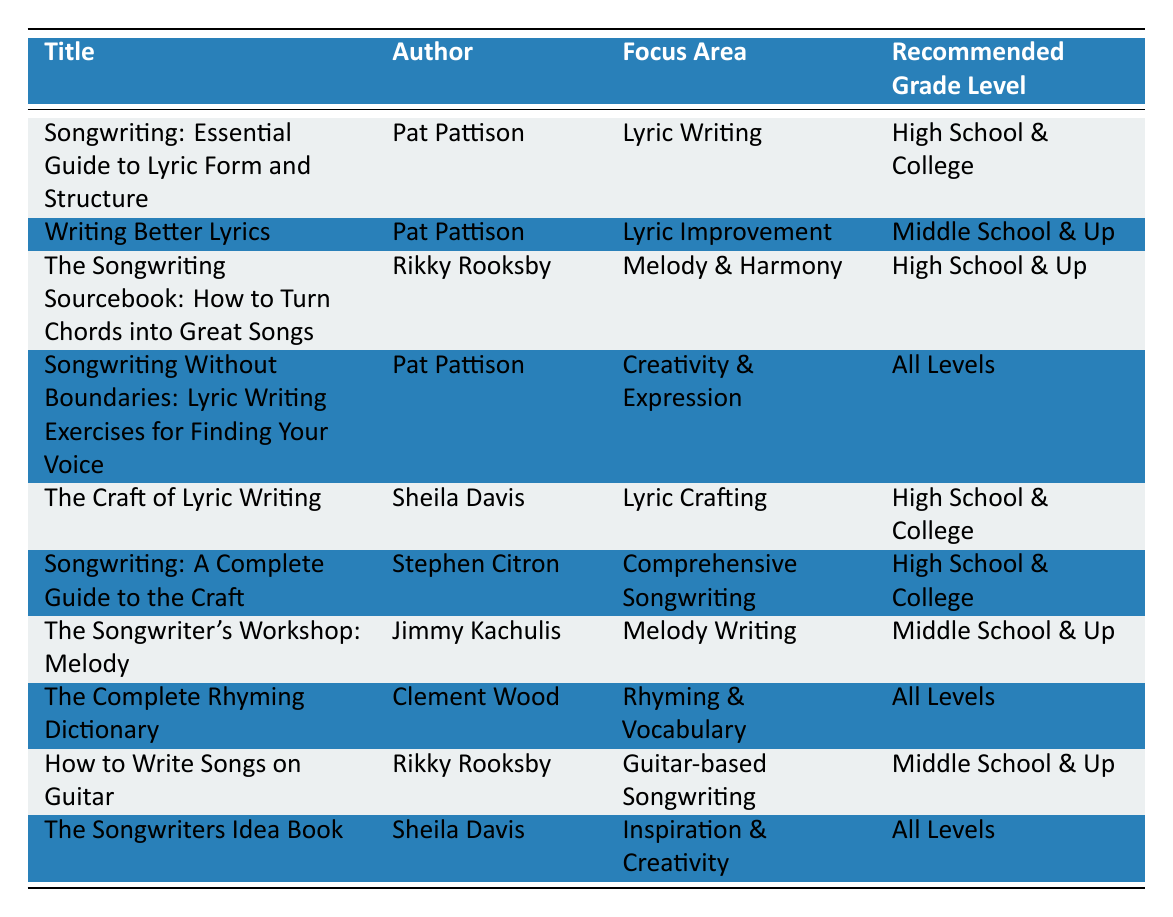What is the title of the book authored by Pat Pattison that focuses on lyric writing? The table lists several works by Pat Pattison, including "Songwriting: Essential Guide to Lyric Form and Structure," which explicitly states its focus on lyric writing.
Answer: Songwriting: Essential Guide to Lyric Form and Structure Which author has written the most books on songwriting in this list? By examining the author column, it is clear that Pat Pattison appears three times, more than any other author, indicating he has contributed the most books on songwriting.
Answer: Pat Pattison Is "The Complete Rhyming Dictionary" recommended for high school students? The recommended grade level for "The Complete Rhyming Dictionary" is listed as "All Levels," so it is suitable for high school students but not specifically targeted for them.
Answer: No What focus area does "The Songwriter's Workshop: Melody" emphasize? In the focus area column, "The Songwriter's Workshop: Melody" is shown to emphasize "Melody Writing," which directly correlates with its title and intended content.
Answer: Melody Writing How many books are recommended for middle school and up? The recommended grade level indicates three books in the middle school and up category: "Writing Better Lyrics," "The Songwriting Sourcebook," and "How to Write Songs on Guitar." Adding them up gives a total of three books.
Answer: 3 True or False: "The Craft of Lyric Writing" is appropriate for all educational levels? The table specifies that "The Craft of Lyric Writing" is recommended for "High School & College," therefore, the assertion that it is appropriate for all educational levels is false.
Answer: False Which book focuses on guitar-based songwriting and what is its author? The table shows "How to Write Songs on Guitar" as focusing on guitar-based songwriting, and it is authored by Rikky Rooksby, making it easy to identify both elements.
Answer: How to Write Songs on Guitar, Rikky Rooksby Identify the book that provides inspiration and creativity along with its author. According to the data, "The Songwriters Idea Book" focuses on inspiration and creativity, and its author is Sheila Davis, allowing us to pinpoint both the title and the author.
Answer: The Songwriters Idea Book, Sheila Davis 